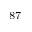<formula> <loc_0><loc_0><loc_500><loc_500>^ { 8 7 }</formula> 